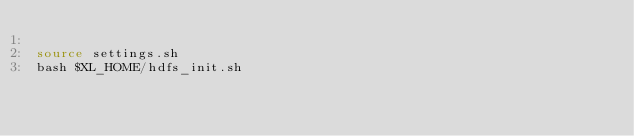<code> <loc_0><loc_0><loc_500><loc_500><_Bash_>
source settings.sh
bash $XL_HOME/hdfs_init.sh</code> 